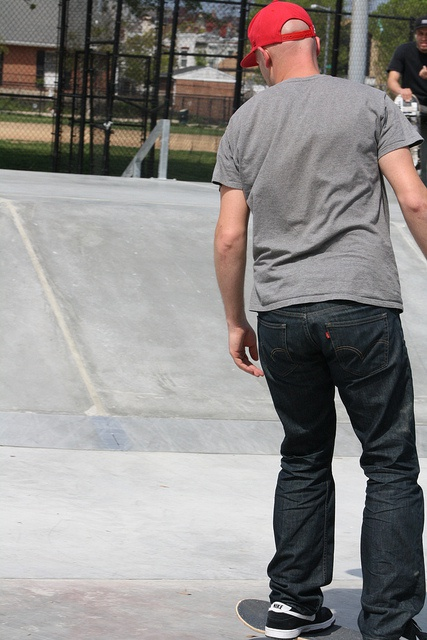Describe the objects in this image and their specific colors. I can see people in gray, black, darkgray, and salmon tones, people in gray, black, tan, and maroon tones, and skateboard in gray, black, darkgray, and lightgray tones in this image. 